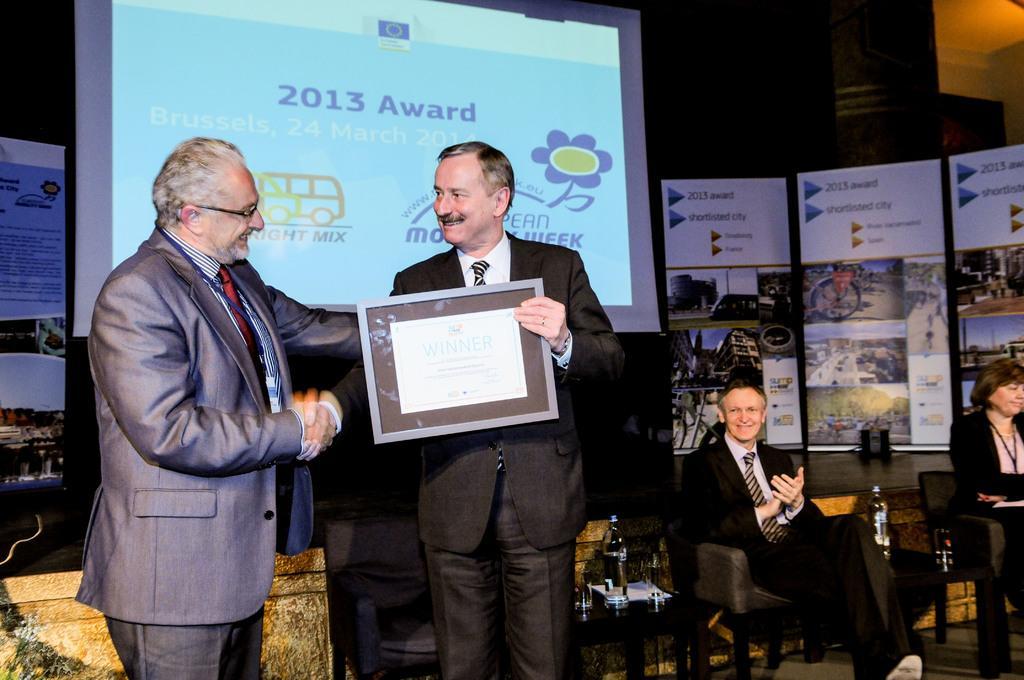Can you describe this image briefly? In this picture we can see there are two people standing and a man is holding an object. On the right side of the people there are two other people sitting on chairs and there are bottles and some objects on the tables. Behind the people, there is a projector screen and banners. 